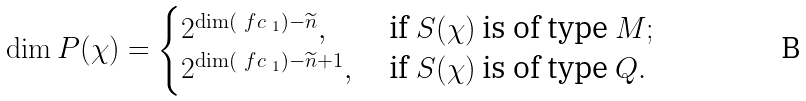Convert formula to latex. <formula><loc_0><loc_0><loc_500><loc_500>\dim P ( \chi ) = \begin{cases} 2 ^ { \dim ( \ f c _ { \ 1 } ) - \widetilde { n } } , & \text { if $S(\chi)$ is of type $M;$} \\ 2 ^ { \dim ( \ f c _ { \ 1 } ) - \widetilde { n } + 1 } , & \text { if $S(\chi)$ is of type $Q.$} \end{cases}</formula> 